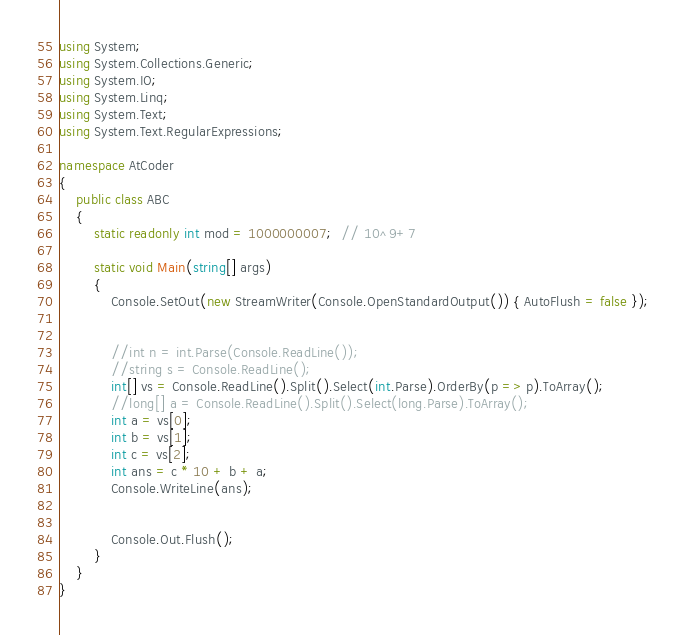<code> <loc_0><loc_0><loc_500><loc_500><_C#_>using System;
using System.Collections.Generic;
using System.IO;
using System.Linq;
using System.Text;
using System.Text.RegularExpressions;

namespace AtCoder
{
	public class ABC
	{
		static readonly int mod = 1000000007;  // 10^9+7

		static void Main(string[] args)
		{
			Console.SetOut(new StreamWriter(Console.OpenStandardOutput()) { AutoFlush = false });


			//int n = int.Parse(Console.ReadLine());
			//string s = Console.ReadLine();
			int[] vs = Console.ReadLine().Split().Select(int.Parse).OrderBy(p => p).ToArray();
			//long[] a = Console.ReadLine().Split().Select(long.Parse).ToArray();
			int a = vs[0];
			int b = vs[1];
			int c = vs[2];
			int ans = c * 10 + b + a;
			Console.WriteLine(ans);


			Console.Out.Flush();
		}
	}
}
</code> 